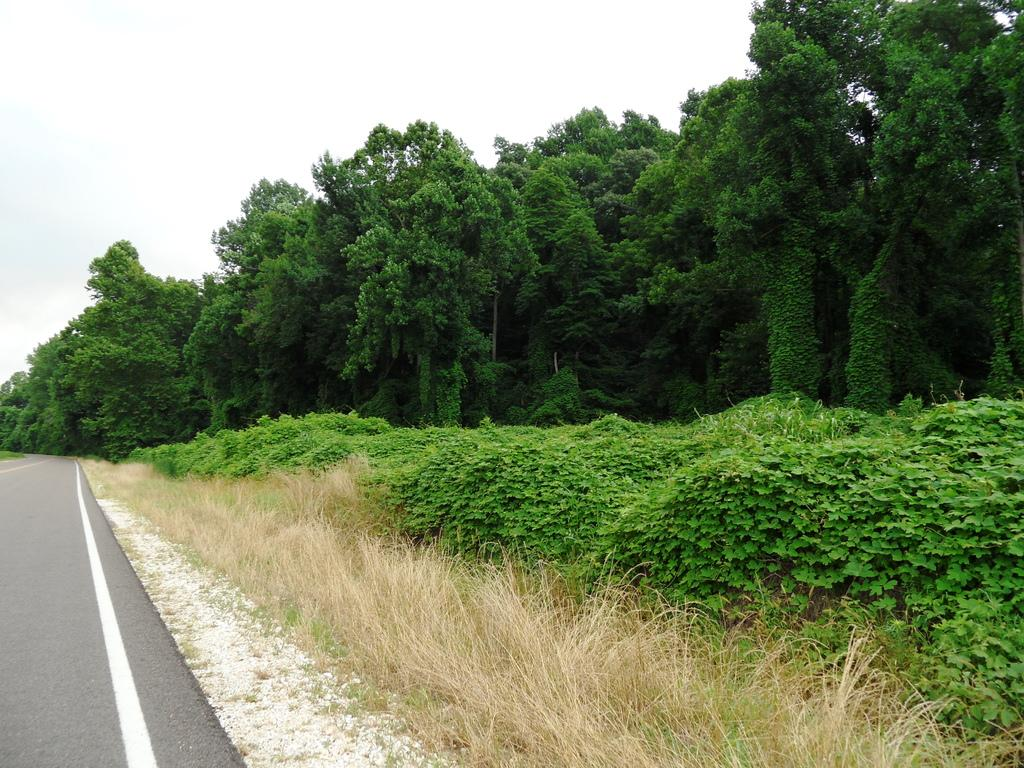What type of surface can be seen in the image? There is a road in the image. What type of vegetation is present in the image? There are plants, grass, and trees in the image. What is visible in the background of the image? The sky is visible in the background of the image. Can you hear the engine of the car driving on the road in the image? There is no sound present in the image, and therefore we cannot hear any engine. Is there a girl visible in the image? There is no mention of a girl in the provided facts, and therefore we cannot confirm her presence in the image. 